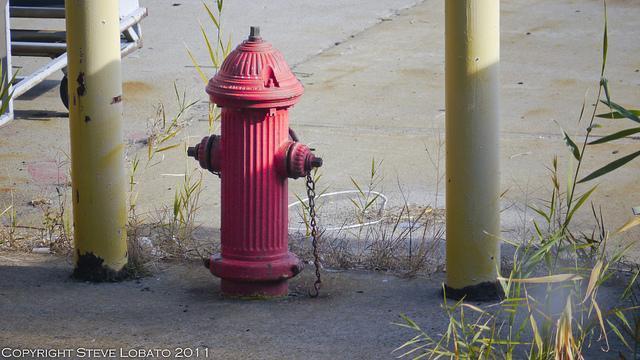How many poles are there?
Give a very brief answer. 2. 